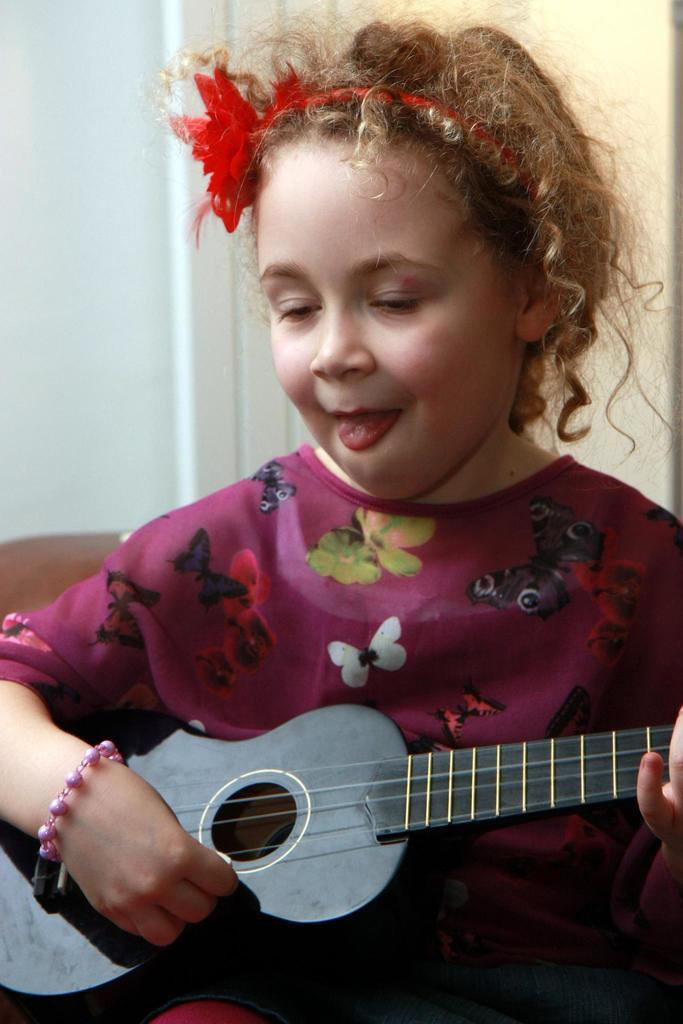What is the main subject of the image? There is a person in the image. What is the person doing in the image? The person is playing a musical instrument. What can be seen in the background of the image? There is a wall in the background of the image. What type of record is the person holding while playing the musical instrument? There is no record present in the image; the person is playing a musical instrument without any visible records. 